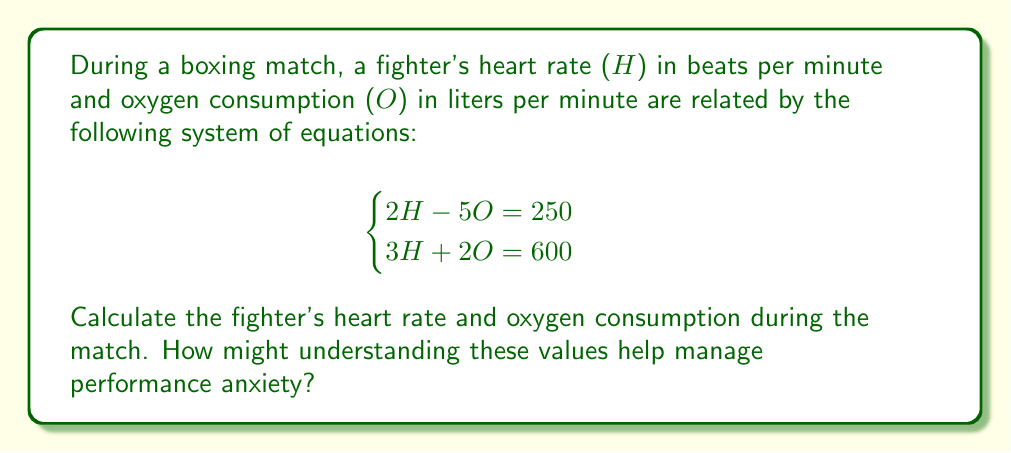Show me your answer to this math problem. Let's solve this system of equations step by step:

1) We have two equations:
   $$\begin{cases}
   2H - 5O = 250 \quad \text{(Equation 1)} \\
   3H + 2O = 600 \quad \text{(Equation 2)}
   \end{cases}$$

2) Let's multiply Equation 1 by 3 and Equation 2 by 2:
   $$\begin{cases}
   6H - 15O = 750 \quad \text{(Equation 3)} \\
   6H + 4O = 1200 \quad \text{(Equation 4)}
   \end{cases}$$

3) Now subtract Equation 3 from Equation 4:
   $$(6H + 4O) - (6H - 15O) = 1200 - 750$$
   $$19O = 450$$

4) Solve for O:
   $$O = \frac{450}{19} \approx 23.68 \text{ L/min}$$

5) Substitute this value of O into Equation 1:
   $$2H - 5(23.68) = 250$$
   $$2H - 118.4 = 250$$
   $$2H = 368.4$$
   $$H = 184.2 \text{ beats/min}$$

Understanding these values can help manage performance anxiety by:
1) Providing objective data to focus on instead of subjective feelings of anxiety.
2) Allowing the boxer to monitor their physiological state and make adjustments.
3) Helping to set realistic expectations and goals for physical performance.
Answer: Heart rate (H) ≈ 184.2 beats/min
Oxygen consumption (O) ≈ 23.68 L/min 